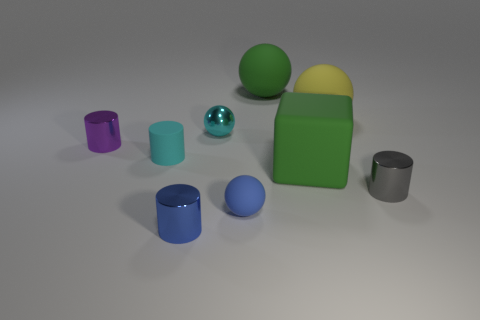There is a object that is the same color as the large rubber block; what is its material?
Ensure brevity in your answer.  Rubber. Are there fewer yellow matte things that are right of the cyan shiny object than things behind the blue metal cylinder?
Ensure brevity in your answer.  Yes. What is the size of the object that is in front of the small purple shiny cylinder and right of the matte block?
Provide a short and direct response. Small. There is a metallic cylinder in front of the tiny blue object that is behind the small blue metal object; is there a small cylinder that is to the left of it?
Your answer should be very brief. Yes. Are any large cyan matte spheres visible?
Your answer should be compact. No. Are there more cyan cylinders on the left side of the blue metallic thing than small gray objects behind the large cube?
Give a very brief answer. Yes. What size is the yellow sphere that is made of the same material as the big green block?
Your response must be concise. Large. There is a cyan cylinder in front of the large yellow rubber sphere that is behind the metallic cylinder in front of the small gray object; what size is it?
Make the answer very short. Small. The tiny object that is right of the big yellow matte sphere is what color?
Provide a succinct answer. Gray. Are there more large things behind the big yellow rubber ball than green objects?
Ensure brevity in your answer.  No. 